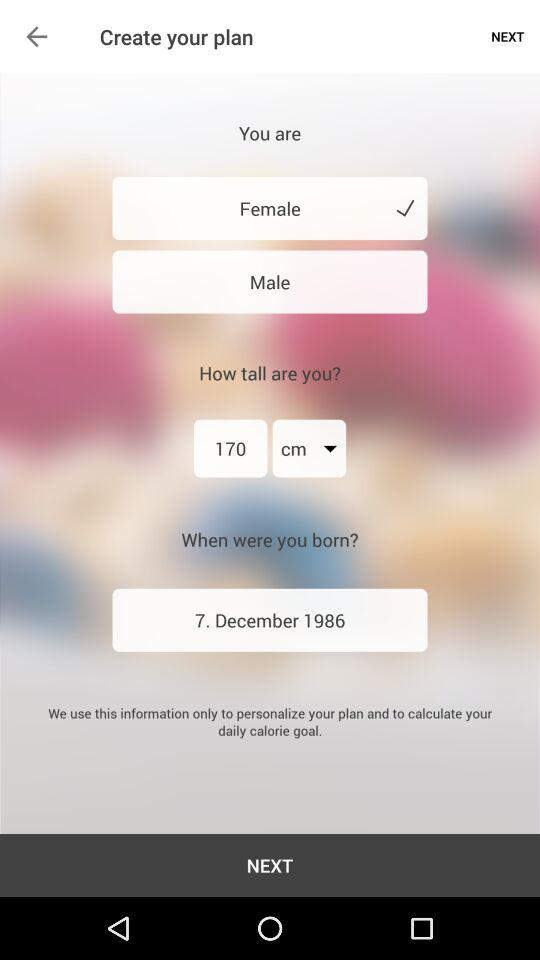What is the gender? The gender is female. 